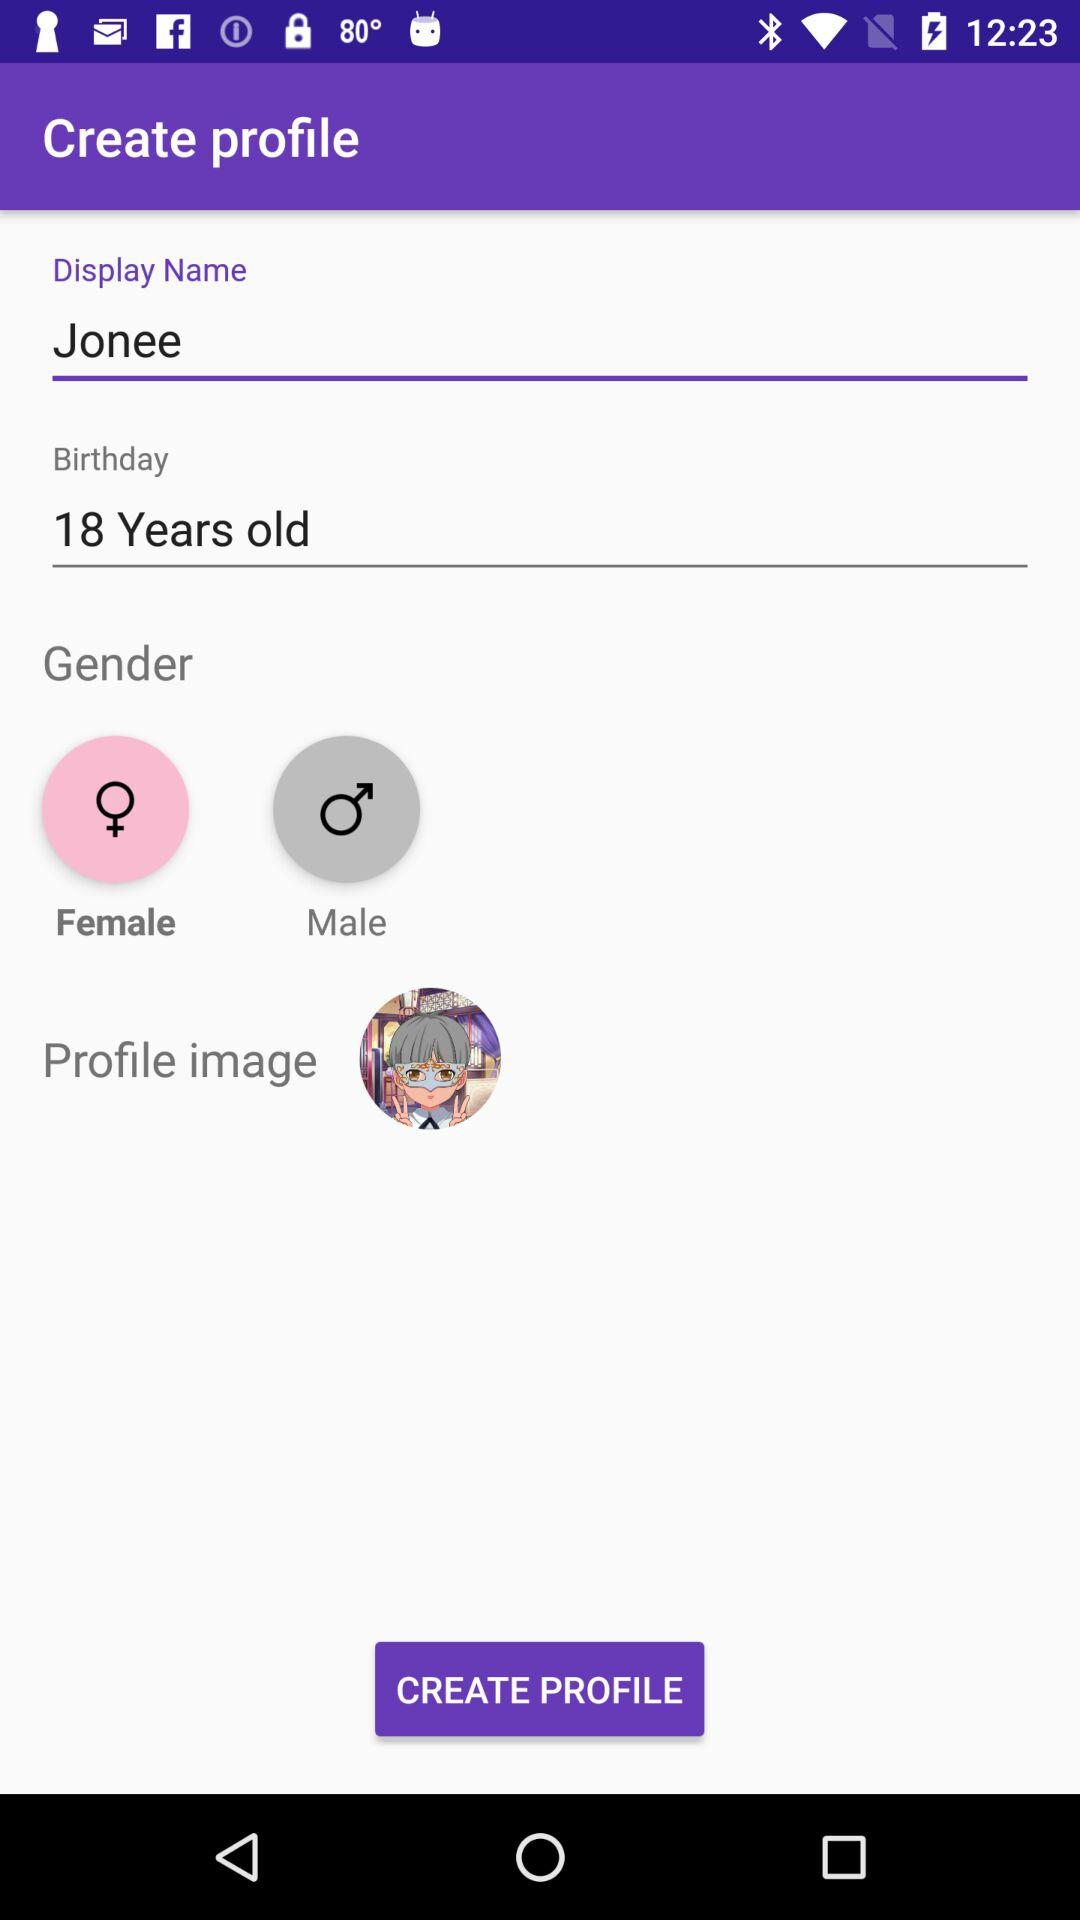What is the user's age? The user is 18 years old. 